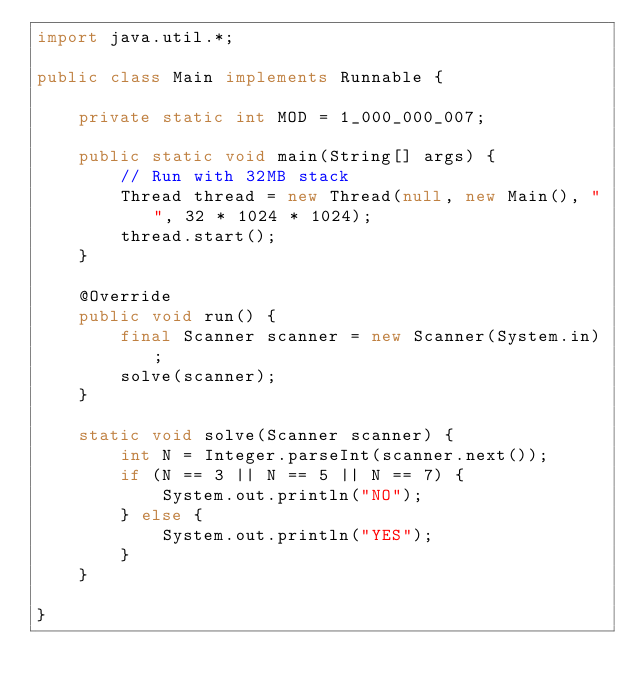<code> <loc_0><loc_0><loc_500><loc_500><_Java_>import java.util.*;

public class Main implements Runnable {

    private static int MOD = 1_000_000_007;

    public static void main(String[] args) {
        // Run with 32MB stack
        Thread thread = new Thread(null, new Main(), "", 32 * 1024 * 1024);
        thread.start();
    }

    @Override
    public void run() {
        final Scanner scanner = new Scanner(System.in);
        solve(scanner);
    }

    static void solve(Scanner scanner) {
        int N = Integer.parseInt(scanner.next());
        if (N == 3 || N == 5 || N == 7) {
            System.out.println("NO");
        } else {
            System.out.println("YES");
        }
    }

}

</code> 